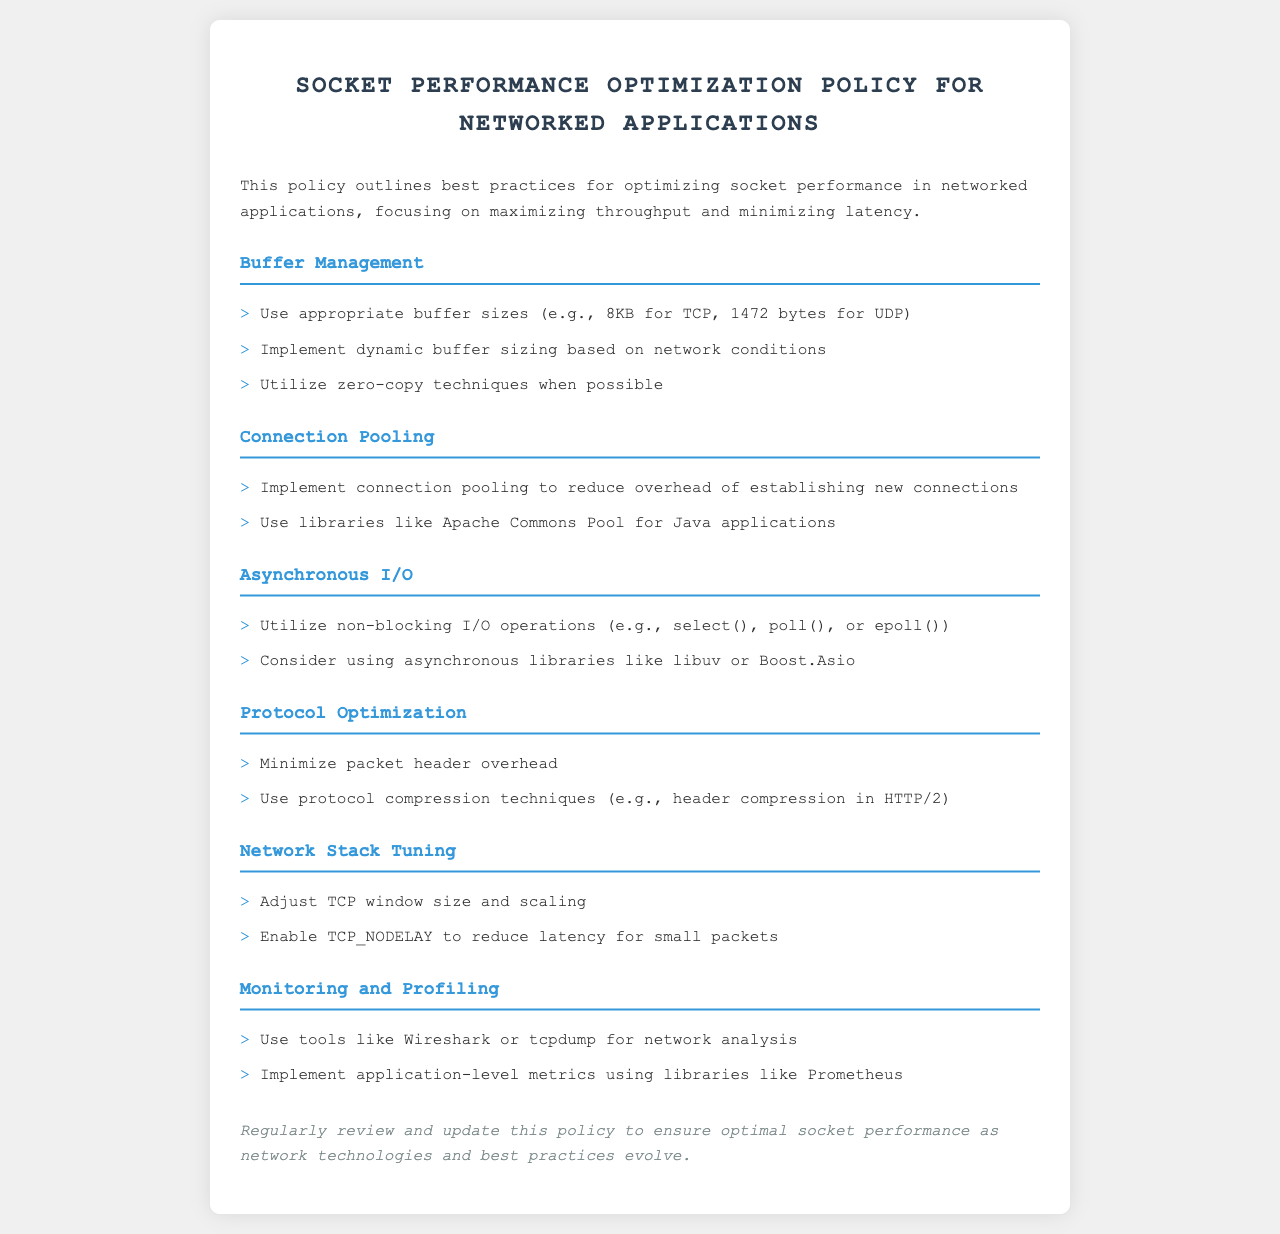What is the primary focus of the policy? The primary focus of the policy is to outline best practices for optimizing socket performance in networked applications, specifically to maximize throughput and minimize latency.
Answer: maximizing throughput and minimizing latency What buffer size is recommended for TCP? The document states that using appropriate buffer sizes, specifically for TCP, should be 8KB.
Answer: 8KB Which technique is suggested for reducing the overhead of establishing new connections? The policy suggests implementing connection pooling to reduce the overhead of establishing new connections.
Answer: connection pooling What should be adjusted to reduce latency for small packets? The document mentions to enable TCP_NODELAY to reduce latency for small packets.
Answer: TCP_NODELAY Name one tool mentioned for network analysis. The document lists Wireshark as one tool for network analysis.
Answer: Wireshark What library is recommended for asynchronous I/O operations? The policy suggests considering using libraries like libuv for asynchronous I/O operations.
Answer: libuv How often should the policy be reviewed? The document states that the policy should be regularly reviewed and updated.
Answer: regularly What is the purpose of using protocol compression techniques? The purpose of using protocol compression techniques is to minimize packet header overhead.
Answer: minimize packet header overhead 